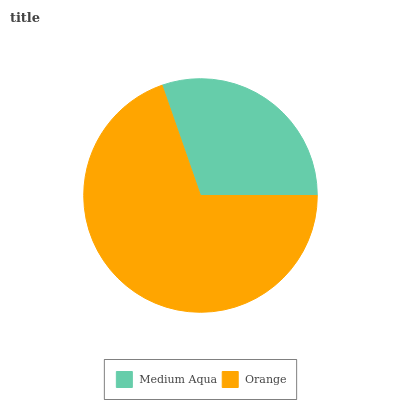Is Medium Aqua the minimum?
Answer yes or no. Yes. Is Orange the maximum?
Answer yes or no. Yes. Is Orange the minimum?
Answer yes or no. No. Is Orange greater than Medium Aqua?
Answer yes or no. Yes. Is Medium Aqua less than Orange?
Answer yes or no. Yes. Is Medium Aqua greater than Orange?
Answer yes or no. No. Is Orange less than Medium Aqua?
Answer yes or no. No. Is Orange the high median?
Answer yes or no. Yes. Is Medium Aqua the low median?
Answer yes or no. Yes. Is Medium Aqua the high median?
Answer yes or no. No. Is Orange the low median?
Answer yes or no. No. 